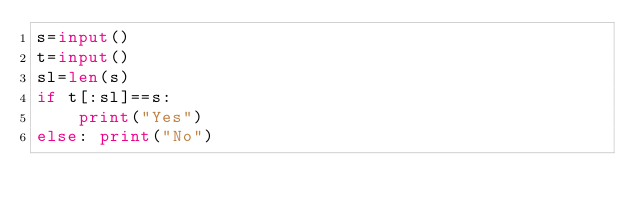Convert code to text. <code><loc_0><loc_0><loc_500><loc_500><_Python_>s=input()
t=input()
sl=len(s)
if t[:sl]==s:
    print("Yes")
else: print("No")</code> 